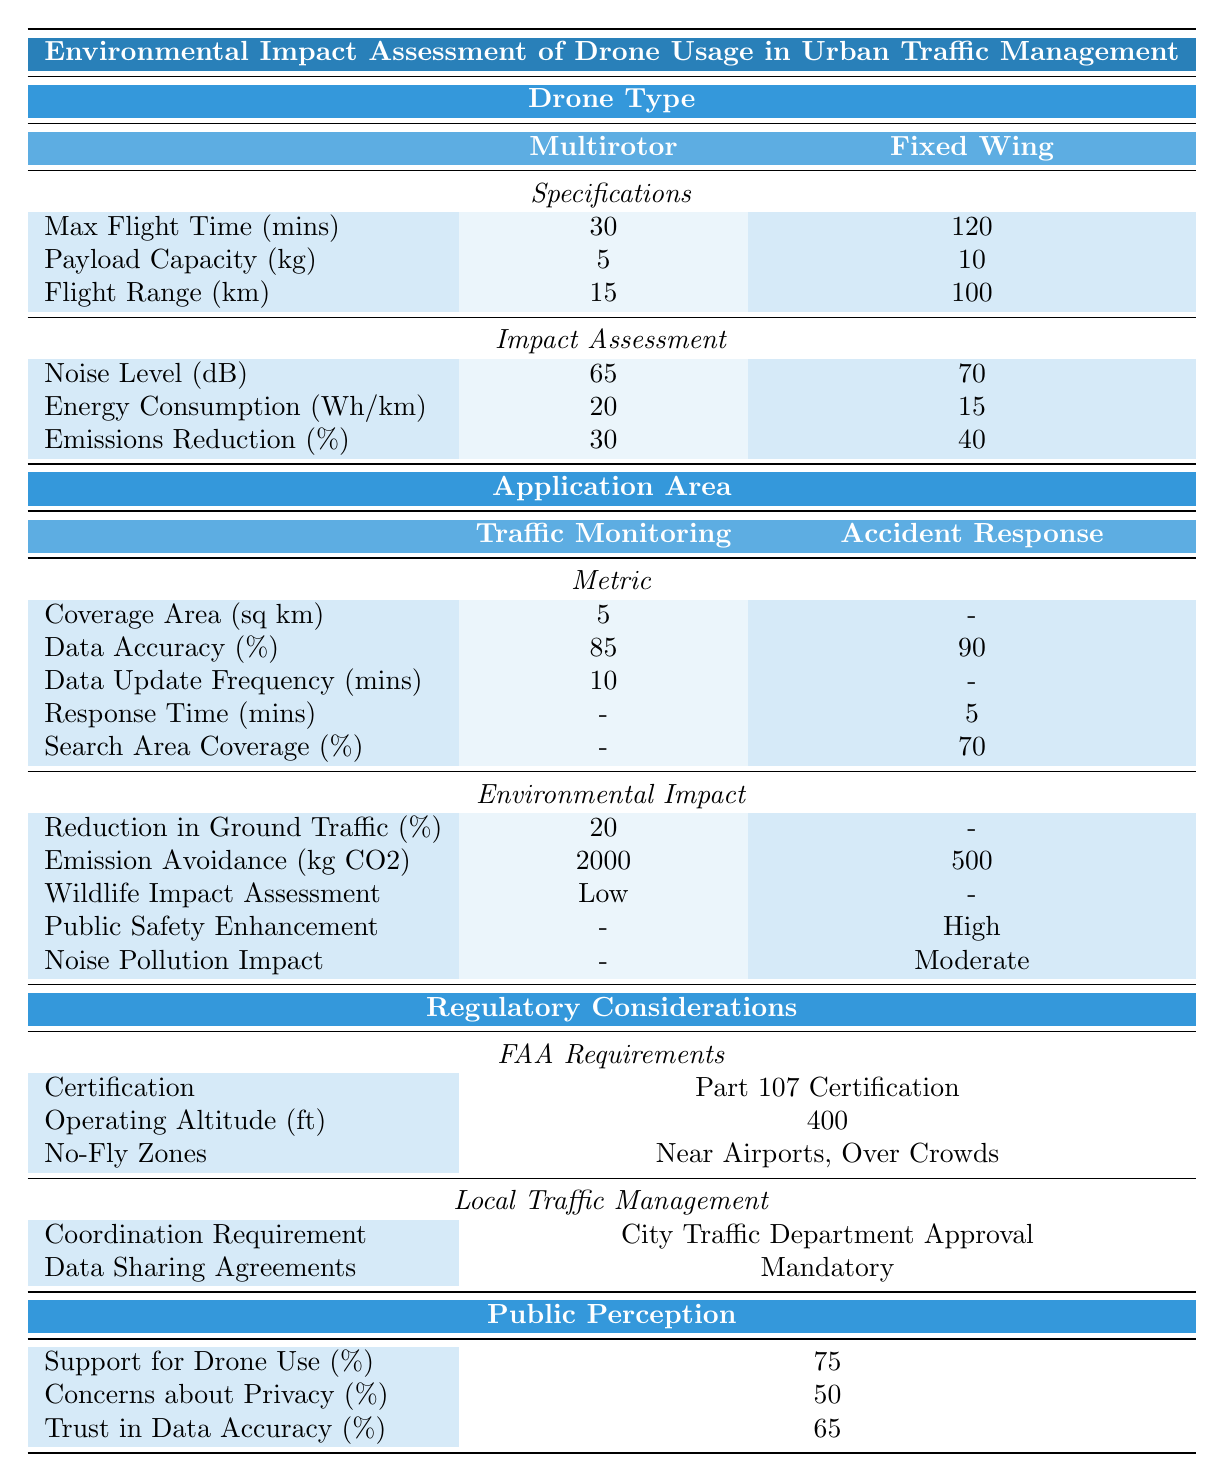What is the maximum flight time of the Multirotor drone? The table indicates that the Multirotor drone has a maximum flight time of 30 minutes.
Answer: 30 minutes How much weight can the Fixed Wing drone carry? According to the table, the Payload Capacity for the Fixed Wing drone is 10 kg.
Answer: 10 kg What is the noise level of the Multirotor drone? The table shows that the Multirotor drone produces a noise level of 65 dB.
Answer: 65 dB What is the emissions reduction percentage for Fixed Wing drones compared to Multirotor drones? The emissions reduction for Fixed Wing is 40% and for Multirotor it is 30%. The difference is 40% - 30% = 10%.
Answer: 10% Which drone type has a longer flight range? The table indicates the Fixed Wing has a flight range of 100 km while the Multirotor has 15 km; hence, Fixed Wing has a longer flight range.
Answer: Fixed Wing What is the public support percentage for drone use in traffic management? The survey results in the table show that 75% of people support the use of drones for traffic management.
Answer: 75% Is the noise pollution impact for accident response classified as high? The table states the noise pollution impact for accident response is classified as moderate, so it is not high.
Answer: No How does the energy consumption of the Fixed Wing drone compare to the Multirotor drone? The Fixed Wing drone consumes 15 Wh/km while the Multirotor consumes 20 Wh/km, making Fixed Wing more efficient.
Answer: Fixed Wing is more efficient What is the average reduction in ground traffic achieved through drone traffic monitoring? The table lists a 20% reduction in ground traffic as a result of traffic monitoring by drones. This value stands as the only representation for traffic monitoring impact.
Answer: 20% What percentage of survey respondents have concerns about privacy in relation to drone usage? The table shows that 50% of respondents have concerns about privacy related to drone usage.
Answer: 50% How much emissions in kg CO2 are avoided through traffic monitoring and accident response combined? The emission avoidance for traffic monitoring is 2000 kg CO2, and for accident response, it is 500 kg CO2. The total is 2000 kg + 500 kg = 2500 kg CO2 avoided.
Answer: 2500 kg CO2 